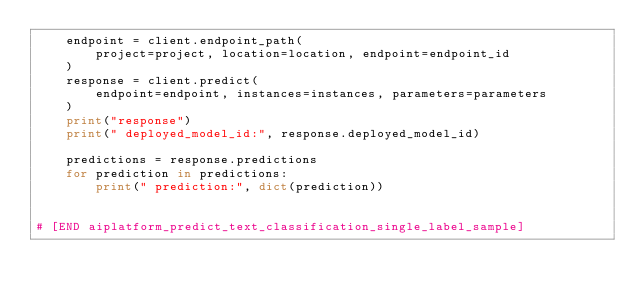<code> <loc_0><loc_0><loc_500><loc_500><_Python_>    endpoint = client.endpoint_path(
        project=project, location=location, endpoint=endpoint_id
    )
    response = client.predict(
        endpoint=endpoint, instances=instances, parameters=parameters
    )
    print("response")
    print(" deployed_model_id:", response.deployed_model_id)

    predictions = response.predictions
    for prediction in predictions:
        print(" prediction:", dict(prediction))


# [END aiplatform_predict_text_classification_single_label_sample]
</code> 